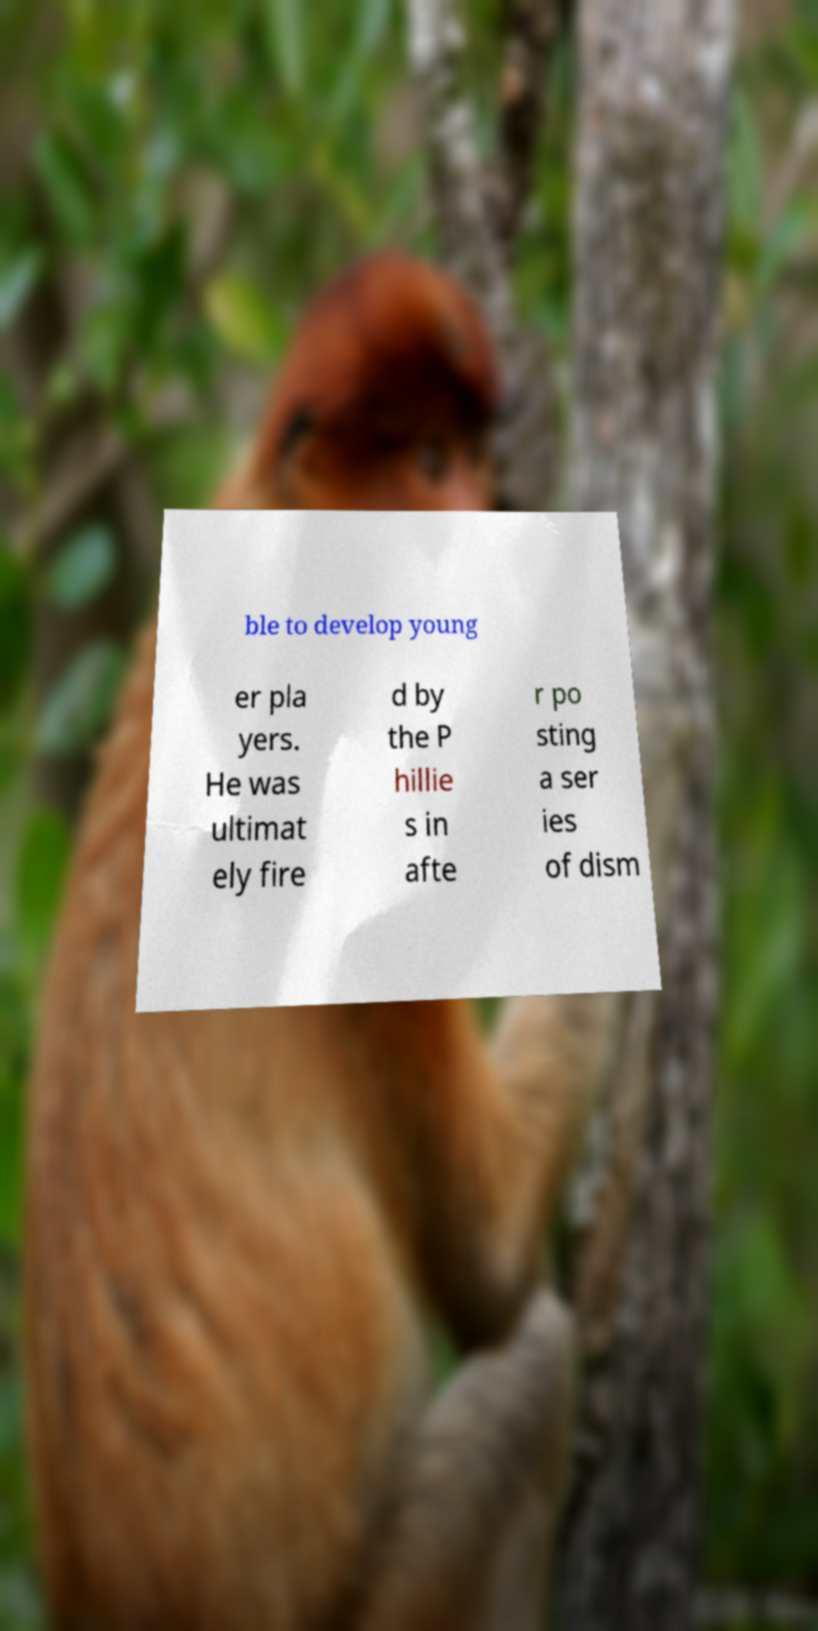What messages or text are displayed in this image? I need them in a readable, typed format. ble to develop young er pla yers. He was ultimat ely fire d by the P hillie s in afte r po sting a ser ies of dism 